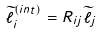<formula> <loc_0><loc_0><loc_500><loc_500>\widetilde { \ell } _ { i } ^ { \left ( i n t \right ) } = R _ { i j } \widetilde { \ell } _ { j }</formula> 